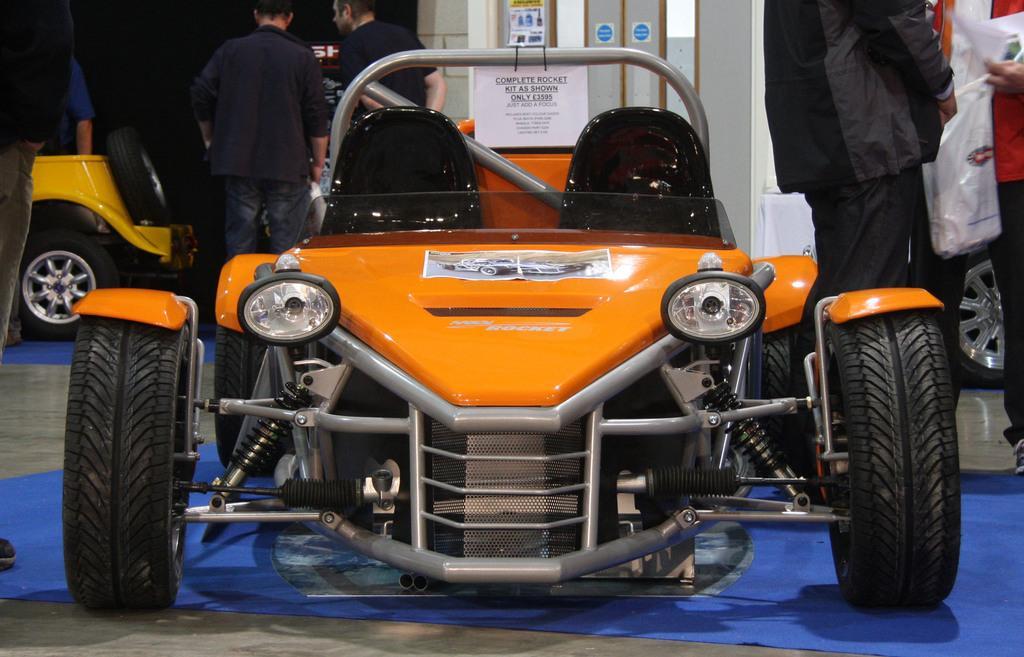Describe this image in one or two sentences. In the foreground of this image, there is a vehicle on the floor and we can also see a blue color carpet. On the right, there are two people and a person is holding papers and a cover. In the background, there are few people standing around a vehicle in the dark and we can also see few posts at the top. 